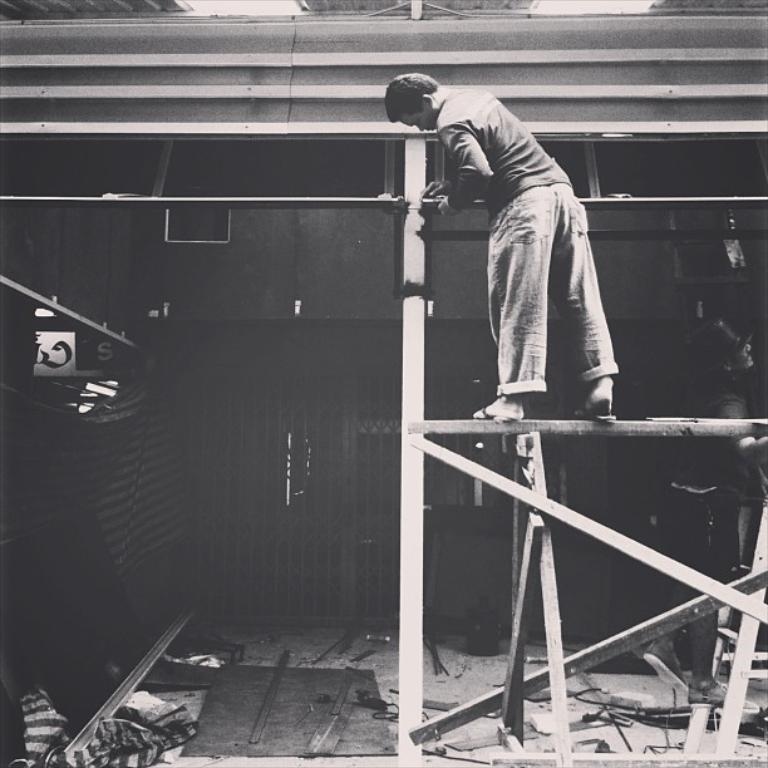What is the man doing in the image? The man is standing on a pole in the image. What is the other person doing in the image? There is a person on a ladder in the image. What type of equipment is visible in the image? Cables and rods are present in the image. What else can be seen in the image besides the man and the person on the ladder? There are other objects in the image. What year is the grandmother celebrating in the image? There is no grandmother or celebration present in the image. What form does the ice cream take in the image? There is no ice cream present in the image. 